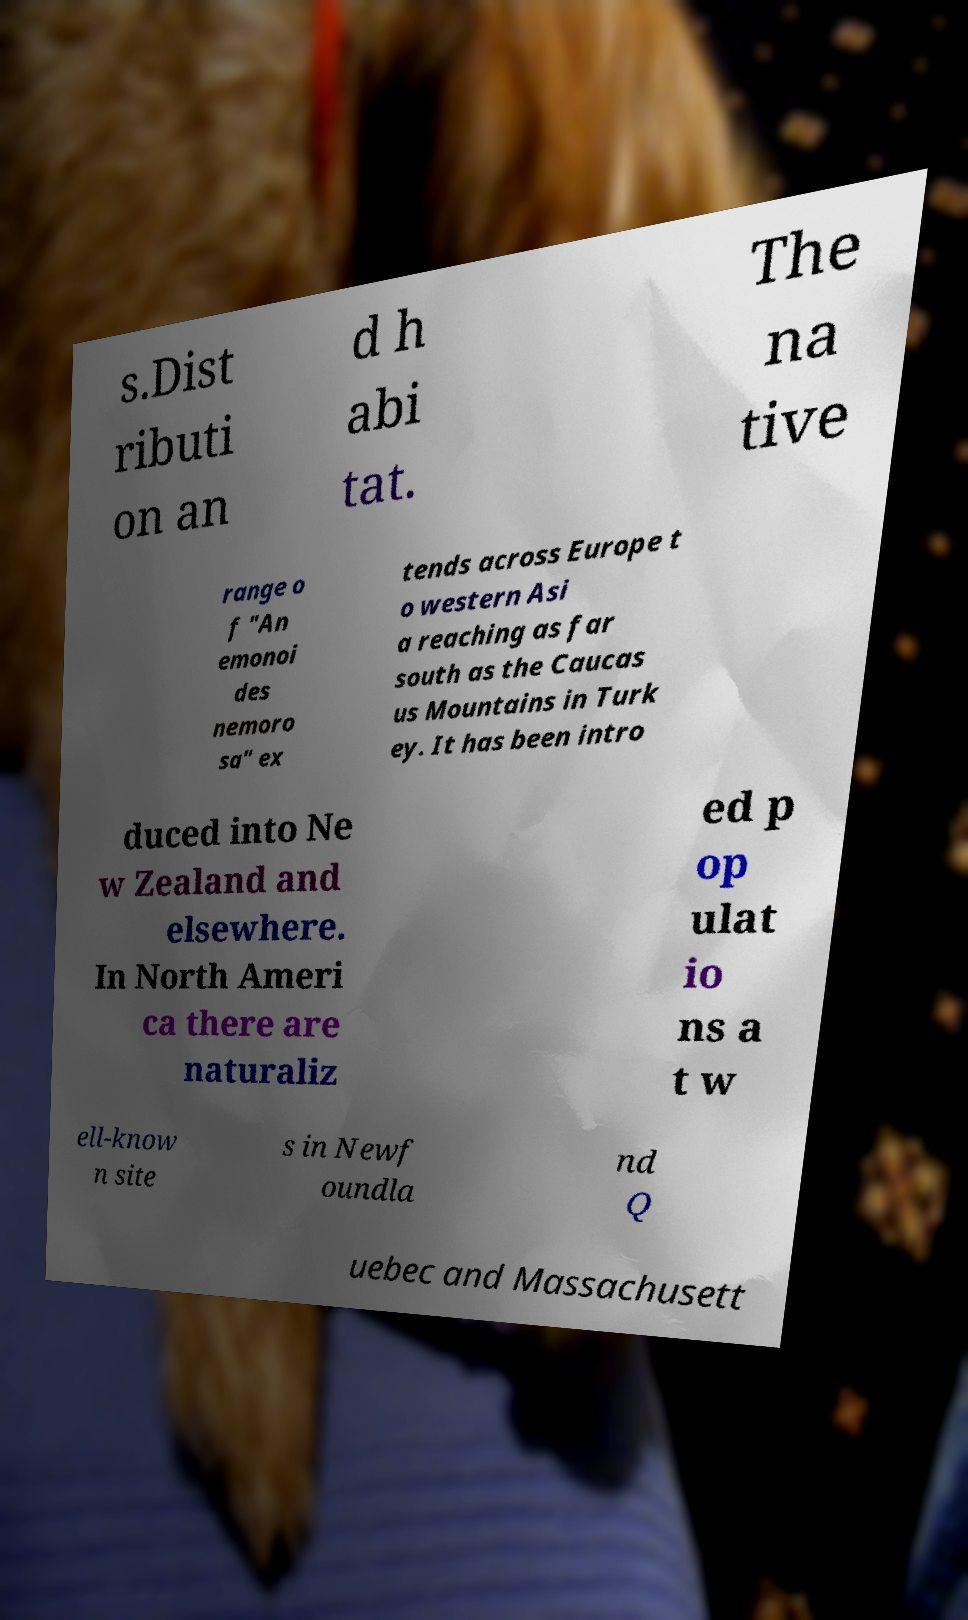Can you accurately transcribe the text from the provided image for me? s.Dist ributi on an d h abi tat. The na tive range o f "An emonoi des nemoro sa" ex tends across Europe t o western Asi a reaching as far south as the Caucas us Mountains in Turk ey. It has been intro duced into Ne w Zealand and elsewhere. In North Ameri ca there are naturaliz ed p op ulat io ns a t w ell-know n site s in Newf oundla nd Q uebec and Massachusett 